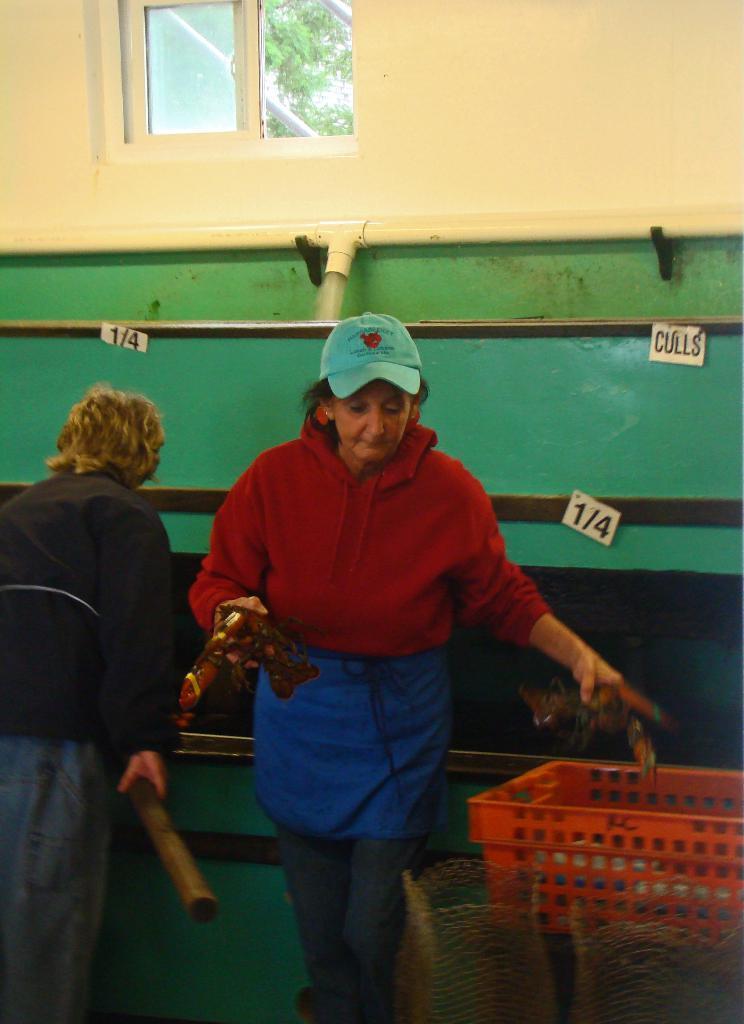Describe this image in one or two sentences. In this image, we can see a few people holding some objects. We can see the wall with some objects. We can also see a basket and some objects at the bottom right corner. We can see the window and some trees. We can see some posters. 